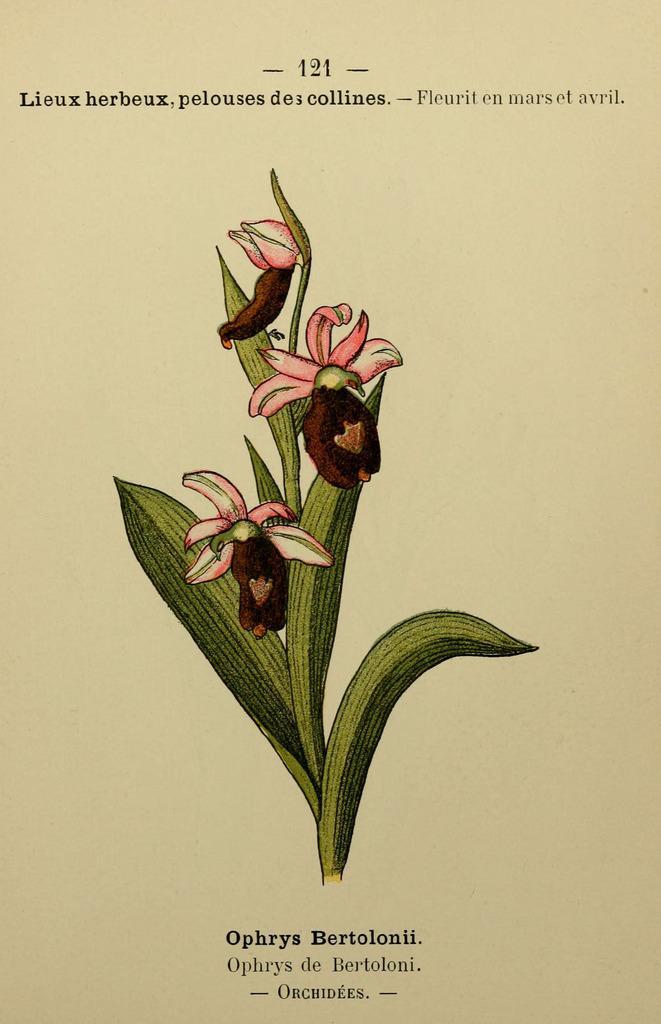How would you summarize this image in a sentence or two? This is a sketch on a paper. In the center of the image we can see a stem, leaves and flowers. In the background of the image we can see the text. 